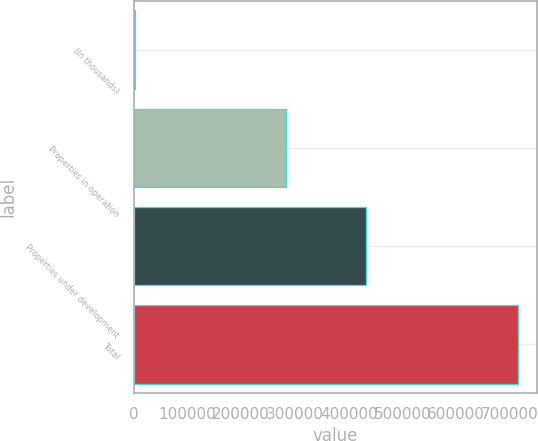Convert chart to OTSL. <chart><loc_0><loc_0><loc_500><loc_500><bar_chart><fcel>(In thousands)<fcel>Properties in operation<fcel>Properties under development<fcel>Total<nl><fcel>2013<fcel>283393<fcel>431849<fcel>715242<nl></chart> 